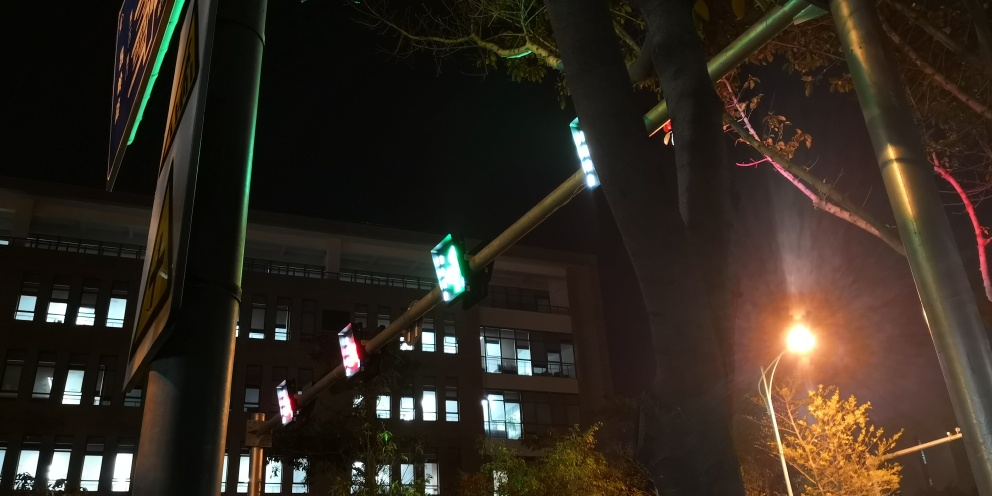How does the color temperature of the lights affect the mood of this night scene? The color temperature of artificial lighting can greatly influence the mood and atmosphere of a night scene. Warmer tones often create a feeling of coziness and comfort, while cooler tones can evoke a sense of calm or sterility. In this image, the varying color temperatures from different light sources add a dynamic and somewhat urban vibe to the scene, suggesting activity and diversity in the environment. 